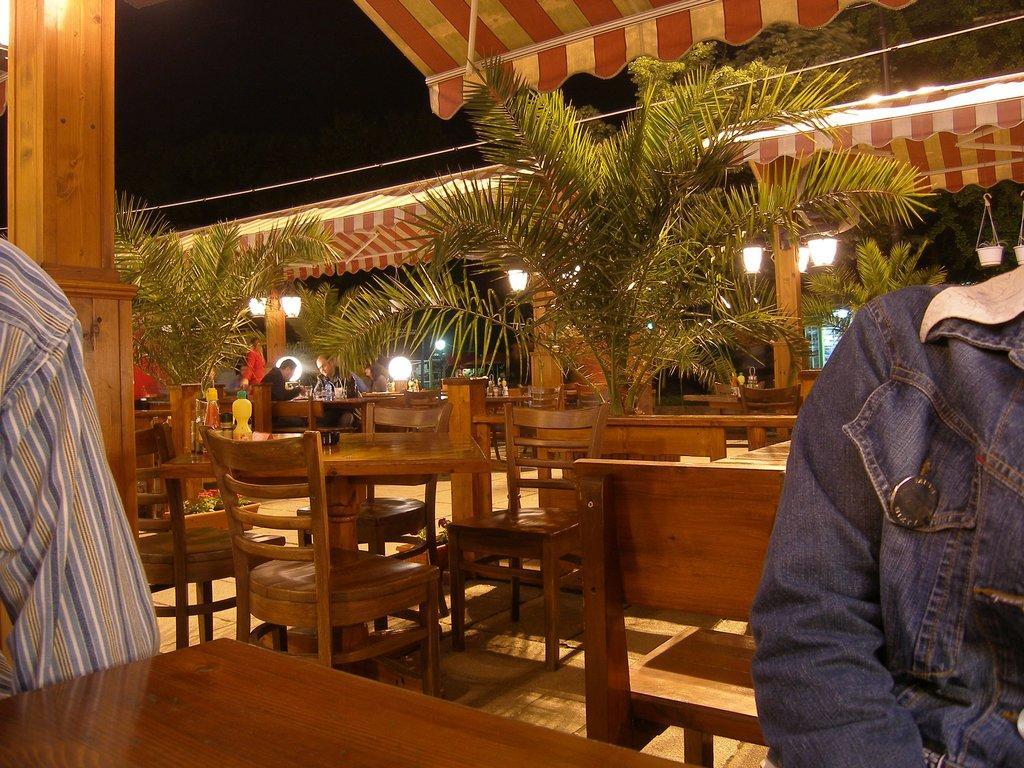Could you give a brief overview of what you see in this image? In this picture we can see some chairs and tables and some plants in between them and two people sitting on the chairs. 